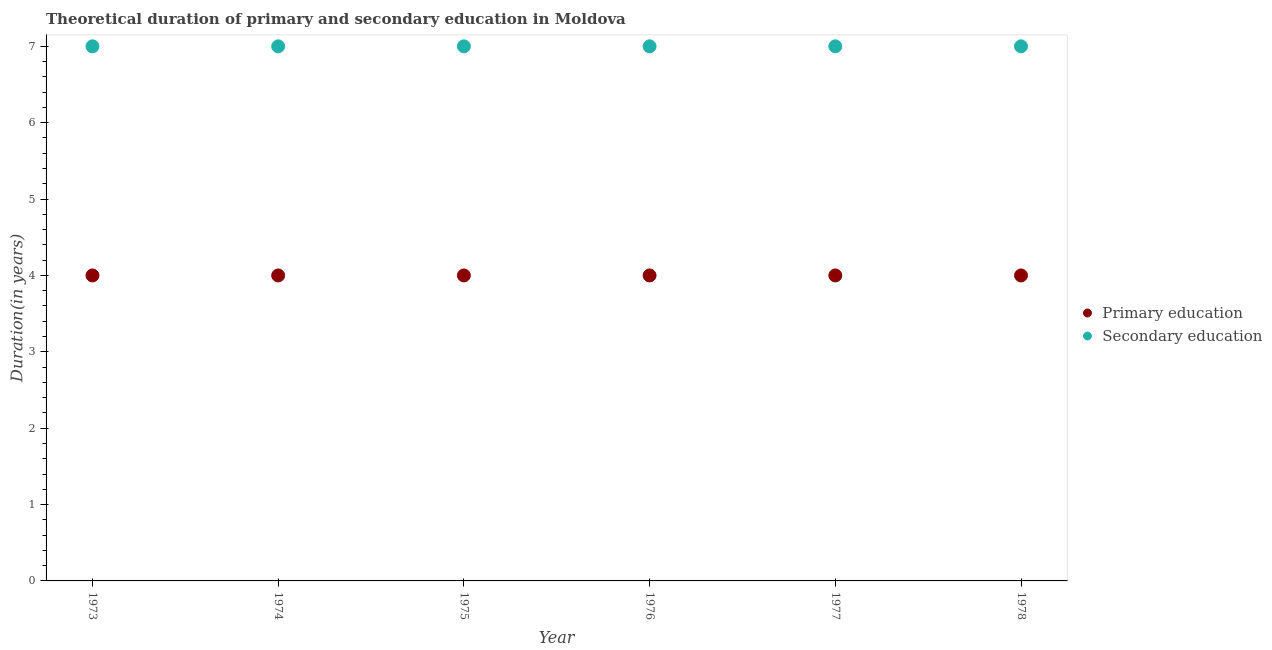Is the number of dotlines equal to the number of legend labels?
Offer a terse response. Yes. What is the duration of secondary education in 1978?
Keep it short and to the point. 7. Across all years, what is the maximum duration of secondary education?
Offer a very short reply. 7. Across all years, what is the minimum duration of primary education?
Offer a terse response. 4. In which year was the duration of primary education maximum?
Your response must be concise. 1973. In which year was the duration of primary education minimum?
Give a very brief answer. 1973. What is the total duration of secondary education in the graph?
Make the answer very short. 42. What is the difference between the duration of secondary education in 1975 and the duration of primary education in 1977?
Give a very brief answer. 3. In the year 1975, what is the difference between the duration of primary education and duration of secondary education?
Keep it short and to the point. -3. What is the ratio of the duration of primary education in 1977 to that in 1978?
Provide a short and direct response. 1. Is the duration of secondary education in 1974 less than that in 1976?
Keep it short and to the point. No. Is the difference between the duration of secondary education in 1975 and 1976 greater than the difference between the duration of primary education in 1975 and 1976?
Keep it short and to the point. No. What is the difference between the highest and the second highest duration of secondary education?
Ensure brevity in your answer.  0. Is the sum of the duration of primary education in 1975 and 1977 greater than the maximum duration of secondary education across all years?
Offer a very short reply. Yes. Is the duration of secondary education strictly less than the duration of primary education over the years?
Provide a succinct answer. No. How many dotlines are there?
Offer a very short reply. 2. How many years are there in the graph?
Your answer should be very brief. 6. Are the values on the major ticks of Y-axis written in scientific E-notation?
Your answer should be compact. No. Does the graph contain any zero values?
Provide a succinct answer. No. Does the graph contain grids?
Keep it short and to the point. No. Where does the legend appear in the graph?
Make the answer very short. Center right. How are the legend labels stacked?
Offer a very short reply. Vertical. What is the title of the graph?
Your response must be concise. Theoretical duration of primary and secondary education in Moldova. What is the label or title of the X-axis?
Provide a short and direct response. Year. What is the label or title of the Y-axis?
Give a very brief answer. Duration(in years). What is the Duration(in years) of Secondary education in 1973?
Your response must be concise. 7. What is the Duration(in years) in Primary education in 1974?
Your response must be concise. 4. What is the Duration(in years) in Primary education in 1975?
Provide a succinct answer. 4. What is the Duration(in years) in Secondary education in 1975?
Make the answer very short. 7. What is the Duration(in years) of Secondary education in 1976?
Offer a terse response. 7. What is the Duration(in years) in Primary education in 1977?
Keep it short and to the point. 4. What is the Duration(in years) of Secondary education in 1977?
Make the answer very short. 7. What is the Duration(in years) in Primary education in 1978?
Your response must be concise. 4. Across all years, what is the maximum Duration(in years) in Secondary education?
Offer a terse response. 7. What is the total Duration(in years) of Secondary education in the graph?
Keep it short and to the point. 42. What is the difference between the Duration(in years) of Primary education in 1973 and that in 1974?
Your answer should be very brief. 0. What is the difference between the Duration(in years) in Secondary education in 1973 and that in 1975?
Make the answer very short. 0. What is the difference between the Duration(in years) of Primary education in 1973 and that in 1977?
Provide a short and direct response. 0. What is the difference between the Duration(in years) in Secondary education in 1974 and that in 1975?
Make the answer very short. 0. What is the difference between the Duration(in years) in Primary education in 1974 and that in 1978?
Offer a very short reply. 0. What is the difference between the Duration(in years) in Secondary education in 1974 and that in 1978?
Keep it short and to the point. 0. What is the difference between the Duration(in years) in Secondary education in 1975 and that in 1976?
Provide a short and direct response. 0. What is the difference between the Duration(in years) of Secondary education in 1975 and that in 1977?
Ensure brevity in your answer.  0. What is the difference between the Duration(in years) in Primary education in 1975 and that in 1978?
Keep it short and to the point. 0. What is the difference between the Duration(in years) in Primary education in 1976 and that in 1977?
Make the answer very short. 0. What is the difference between the Duration(in years) of Secondary education in 1976 and that in 1977?
Provide a succinct answer. 0. What is the difference between the Duration(in years) in Primary education in 1976 and that in 1978?
Your response must be concise. 0. What is the difference between the Duration(in years) of Primary education in 1977 and that in 1978?
Your answer should be compact. 0. What is the difference between the Duration(in years) of Primary education in 1973 and the Duration(in years) of Secondary education in 1978?
Your response must be concise. -3. What is the difference between the Duration(in years) of Primary education in 1974 and the Duration(in years) of Secondary education in 1976?
Offer a very short reply. -3. What is the difference between the Duration(in years) of Primary education in 1975 and the Duration(in years) of Secondary education in 1976?
Offer a very short reply. -3. What is the difference between the Duration(in years) in Primary education in 1976 and the Duration(in years) in Secondary education in 1977?
Make the answer very short. -3. What is the difference between the Duration(in years) of Primary education in 1976 and the Duration(in years) of Secondary education in 1978?
Provide a succinct answer. -3. In the year 1975, what is the difference between the Duration(in years) of Primary education and Duration(in years) of Secondary education?
Your answer should be compact. -3. In the year 1978, what is the difference between the Duration(in years) in Primary education and Duration(in years) in Secondary education?
Provide a succinct answer. -3. What is the ratio of the Duration(in years) in Primary education in 1973 to that in 1974?
Your answer should be very brief. 1. What is the ratio of the Duration(in years) in Secondary education in 1973 to that in 1974?
Provide a short and direct response. 1. What is the ratio of the Duration(in years) of Primary education in 1973 to that in 1976?
Offer a terse response. 1. What is the ratio of the Duration(in years) in Primary education in 1973 to that in 1977?
Your answer should be very brief. 1. What is the ratio of the Duration(in years) in Primary education in 1973 to that in 1978?
Your answer should be very brief. 1. What is the ratio of the Duration(in years) in Secondary education in 1973 to that in 1978?
Your response must be concise. 1. What is the ratio of the Duration(in years) of Primary education in 1974 to that in 1975?
Make the answer very short. 1. What is the ratio of the Duration(in years) in Secondary education in 1974 to that in 1976?
Ensure brevity in your answer.  1. What is the ratio of the Duration(in years) of Secondary education in 1974 to that in 1978?
Make the answer very short. 1. What is the ratio of the Duration(in years) of Primary education in 1975 to that in 1976?
Your response must be concise. 1. What is the ratio of the Duration(in years) in Primary education in 1975 to that in 1977?
Ensure brevity in your answer.  1. What is the ratio of the Duration(in years) of Secondary education in 1975 to that in 1977?
Give a very brief answer. 1. What is the ratio of the Duration(in years) in Primary education in 1975 to that in 1978?
Your answer should be very brief. 1. What is the ratio of the Duration(in years) of Secondary education in 1975 to that in 1978?
Provide a succinct answer. 1. What is the ratio of the Duration(in years) in Primary education in 1976 to that in 1977?
Offer a very short reply. 1. What is the ratio of the Duration(in years) of Secondary education in 1976 to that in 1977?
Ensure brevity in your answer.  1. What is the ratio of the Duration(in years) of Primary education in 1976 to that in 1978?
Your response must be concise. 1. What is the ratio of the Duration(in years) of Secondary education in 1976 to that in 1978?
Provide a succinct answer. 1. What is the difference between the highest and the lowest Duration(in years) in Secondary education?
Your answer should be very brief. 0. 